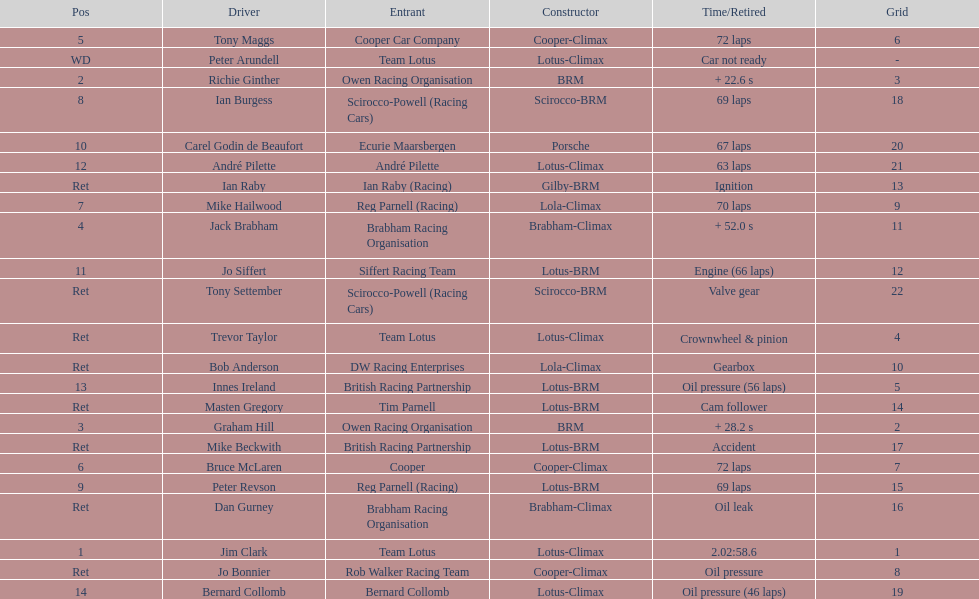Help me parse the entirety of this table. {'header': ['Pos', 'Driver', 'Entrant', 'Constructor', 'Time/Retired', 'Grid'], 'rows': [['5', 'Tony Maggs', 'Cooper Car Company', 'Cooper-Climax', '72 laps', '6'], ['WD', 'Peter Arundell', 'Team Lotus', 'Lotus-Climax', 'Car not ready', '-'], ['2', 'Richie Ginther', 'Owen Racing Organisation', 'BRM', '+ 22.6 s', '3'], ['8', 'Ian Burgess', 'Scirocco-Powell (Racing Cars)', 'Scirocco-BRM', '69 laps', '18'], ['10', 'Carel Godin de Beaufort', 'Ecurie Maarsbergen', 'Porsche', '67 laps', '20'], ['12', 'André Pilette', 'André Pilette', 'Lotus-Climax', '63 laps', '21'], ['Ret', 'Ian Raby', 'Ian Raby (Racing)', 'Gilby-BRM', 'Ignition', '13'], ['7', 'Mike Hailwood', 'Reg Parnell (Racing)', 'Lola-Climax', '70 laps', '9'], ['4', 'Jack Brabham', 'Brabham Racing Organisation', 'Brabham-Climax', '+ 52.0 s', '11'], ['11', 'Jo Siffert', 'Siffert Racing Team', 'Lotus-BRM', 'Engine (66 laps)', '12'], ['Ret', 'Tony Settember', 'Scirocco-Powell (Racing Cars)', 'Scirocco-BRM', 'Valve gear', '22'], ['Ret', 'Trevor Taylor', 'Team Lotus', 'Lotus-Climax', 'Crownwheel & pinion', '4'], ['Ret', 'Bob Anderson', 'DW Racing Enterprises', 'Lola-Climax', 'Gearbox', '10'], ['13', 'Innes Ireland', 'British Racing Partnership', 'Lotus-BRM', 'Oil pressure (56 laps)', '5'], ['Ret', 'Masten Gregory', 'Tim Parnell', 'Lotus-BRM', 'Cam follower', '14'], ['3', 'Graham Hill', 'Owen Racing Organisation', 'BRM', '+ 28.2 s', '2'], ['Ret', 'Mike Beckwith', 'British Racing Partnership', 'Lotus-BRM', 'Accident', '17'], ['6', 'Bruce McLaren', 'Cooper', 'Cooper-Climax', '72 laps', '7'], ['9', 'Peter Revson', 'Reg Parnell (Racing)', 'Lotus-BRM', '69 laps', '15'], ['Ret', 'Dan Gurney', 'Brabham Racing Organisation', 'Brabham-Climax', 'Oil leak', '16'], ['1', 'Jim Clark', 'Team Lotus', 'Lotus-Climax', '2.02:58.6', '1'], ['Ret', 'Jo Bonnier', 'Rob Walker Racing Team', 'Cooper-Climax', 'Oil pressure', '8'], ['14', 'Bernard Collomb', 'Bernard Collomb', 'Lotus-Climax', 'Oil pressure (46 laps)', '19']]} What is the number of americans in the top 5? 1. 